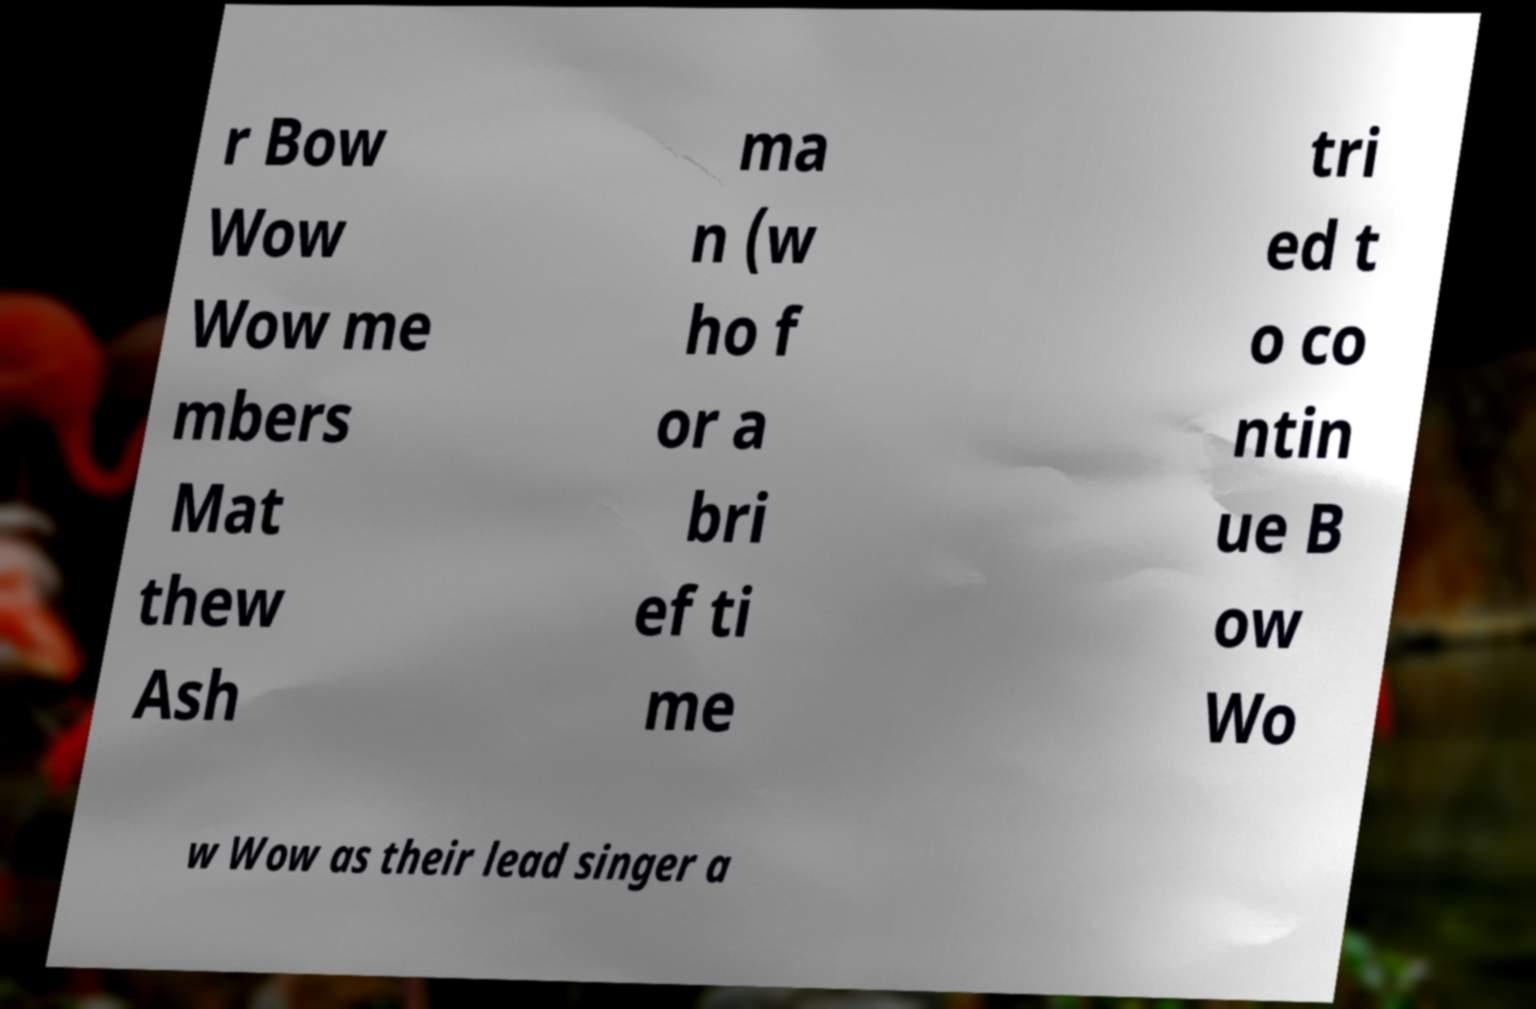Please read and relay the text visible in this image. What does it say? r Bow Wow Wow me mbers Mat thew Ash ma n (w ho f or a bri ef ti me tri ed t o co ntin ue B ow Wo w Wow as their lead singer a 